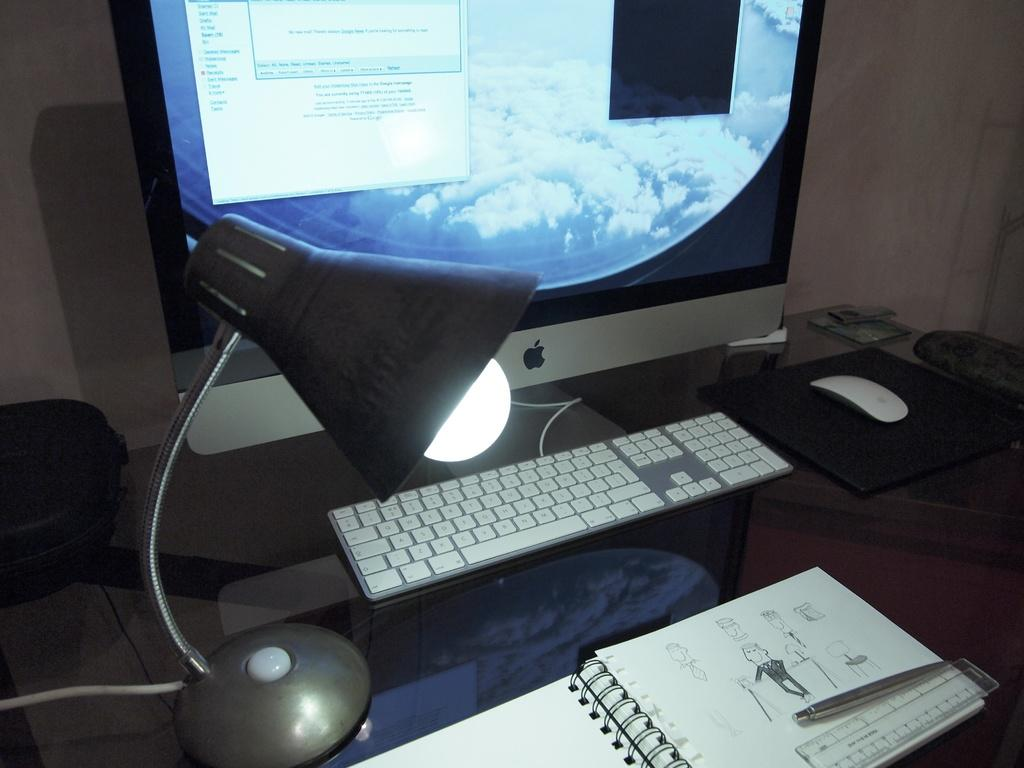<image>
Describe the image concisely. A sketchpad is open in front of an Apple desktop computer. 